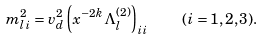<formula> <loc_0><loc_0><loc_500><loc_500>m _ { l i } ^ { 2 } = v _ { d } ^ { 2 } \left ( x ^ { - 2 k } \Lambda _ { l } ^ { ( 2 ) } \right ) _ { i i } \quad ( i = 1 , 2 , 3 ) .</formula> 